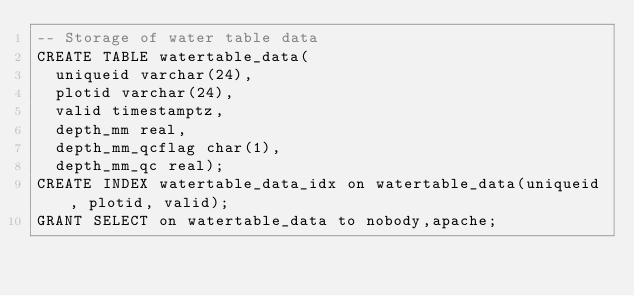<code> <loc_0><loc_0><loc_500><loc_500><_SQL_>-- Storage of water table data
CREATE TABLE watertable_data(
  uniqueid varchar(24),
  plotid varchar(24),
  valid timestamptz,
  depth_mm real,
  depth_mm_qcflag char(1),
  depth_mm_qc real);
CREATE INDEX watertable_data_idx on watertable_data(uniqueid, plotid, valid);
GRANT SELECT on watertable_data to nobody,apache;
</code> 